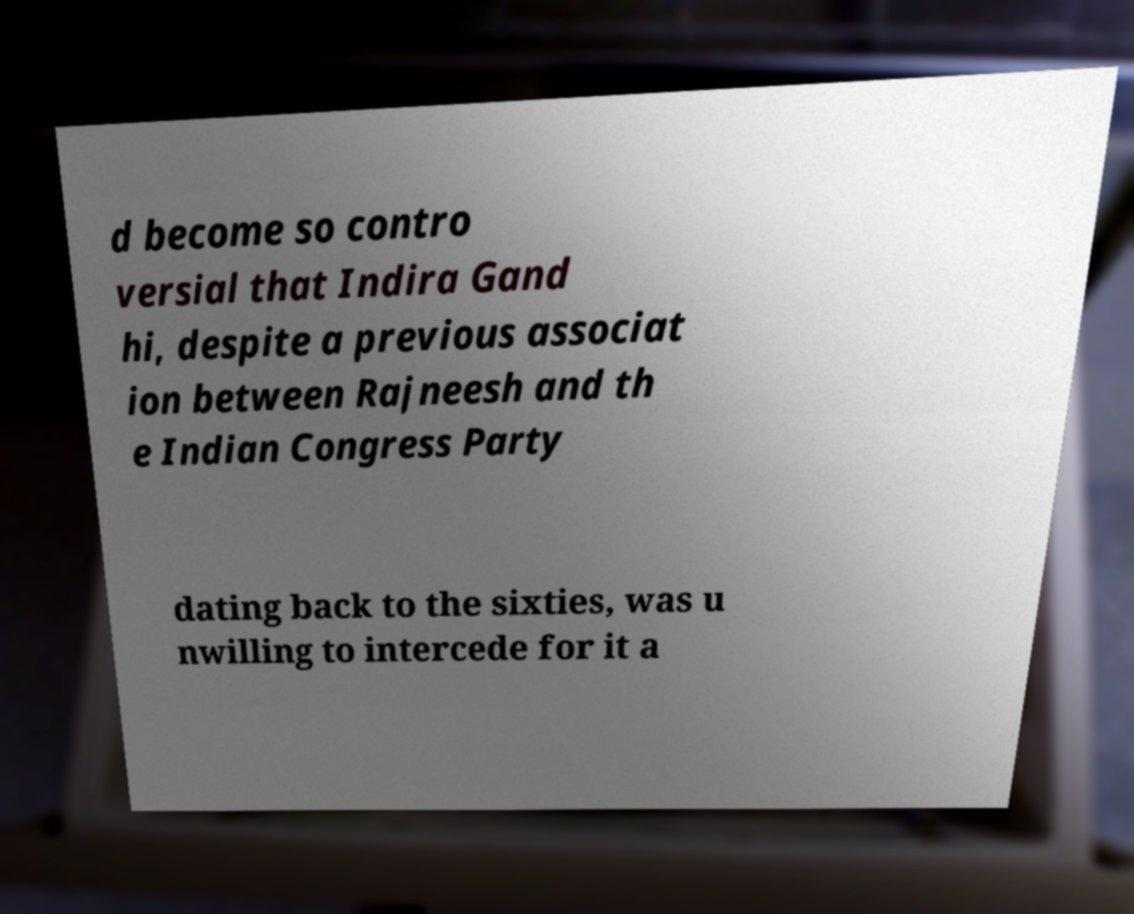I need the written content from this picture converted into text. Can you do that? d become so contro versial that Indira Gand hi, despite a previous associat ion between Rajneesh and th e Indian Congress Party dating back to the sixties, was u nwilling to intercede for it a 